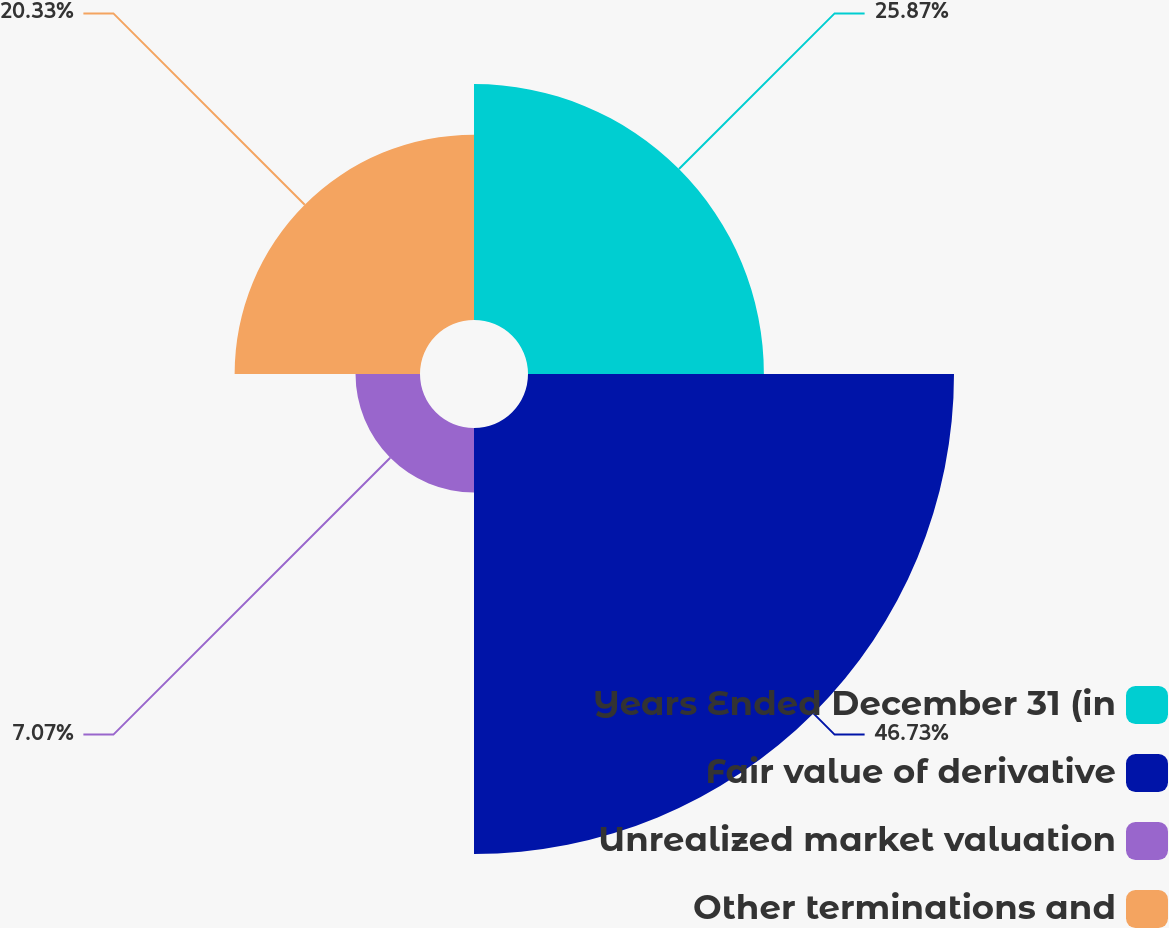Convert chart. <chart><loc_0><loc_0><loc_500><loc_500><pie_chart><fcel>Years Ended December 31 (in<fcel>Fair value of derivative<fcel>Unrealized market valuation<fcel>Other terminations and<nl><fcel>25.87%<fcel>46.72%<fcel>7.07%<fcel>20.33%<nl></chart> 